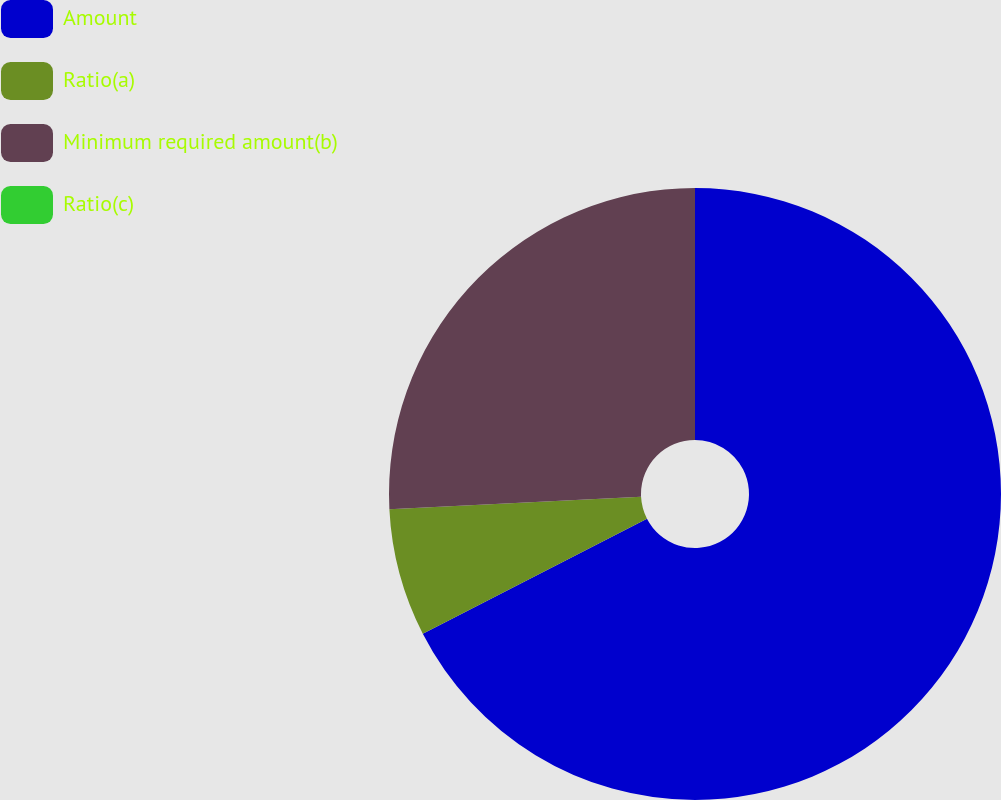Convert chart to OTSL. <chart><loc_0><loc_0><loc_500><loc_500><pie_chart><fcel>Amount<fcel>Ratio(a)<fcel>Minimum required amount(b)<fcel>Ratio(c)<nl><fcel>67.45%<fcel>6.75%<fcel>25.8%<fcel>0.0%<nl></chart> 